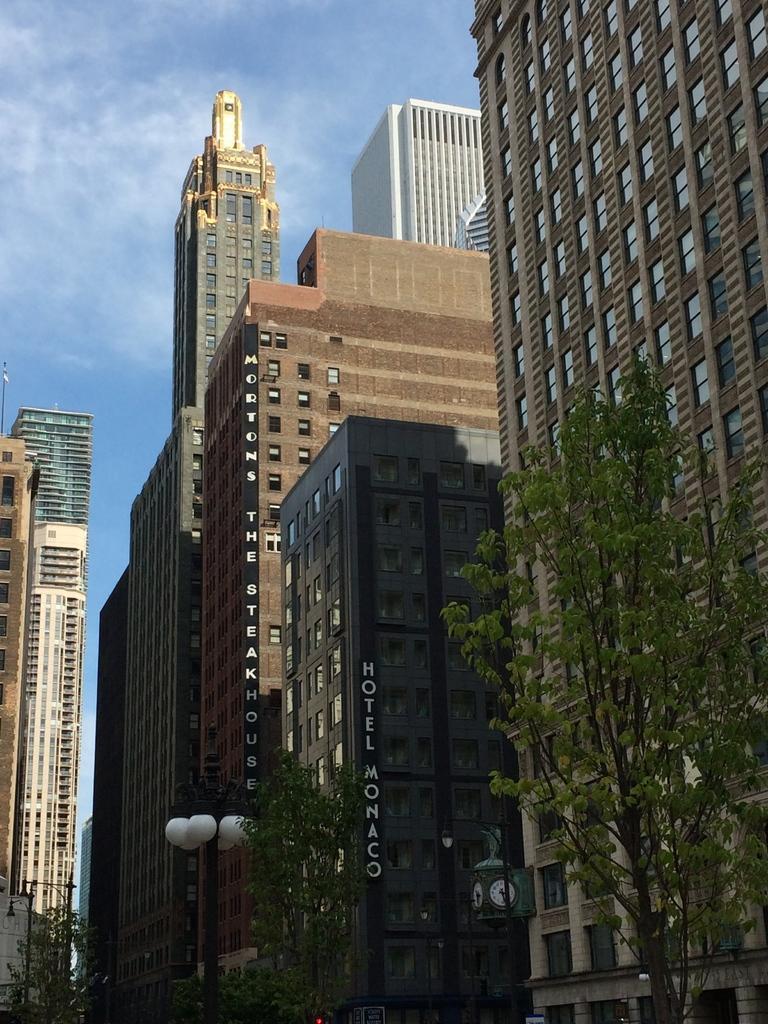Please provide a concise description of this image. In this image, we can see some buildings, there are some trees, we can see some lights, at the top there is a blue sky. 